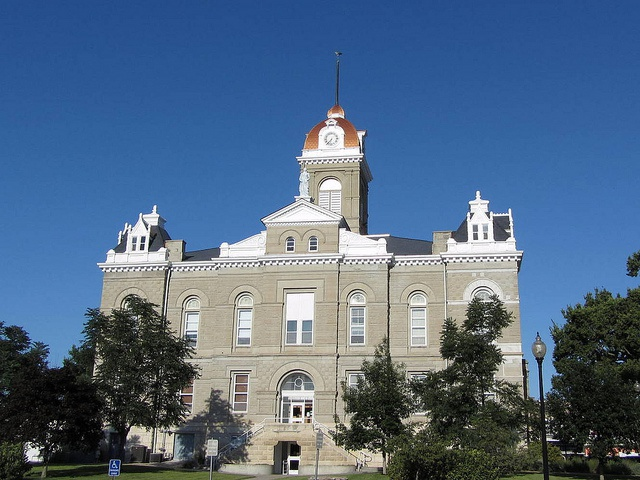Describe the objects in this image and their specific colors. I can see a clock in blue, lightgray, darkgray, and gray tones in this image. 